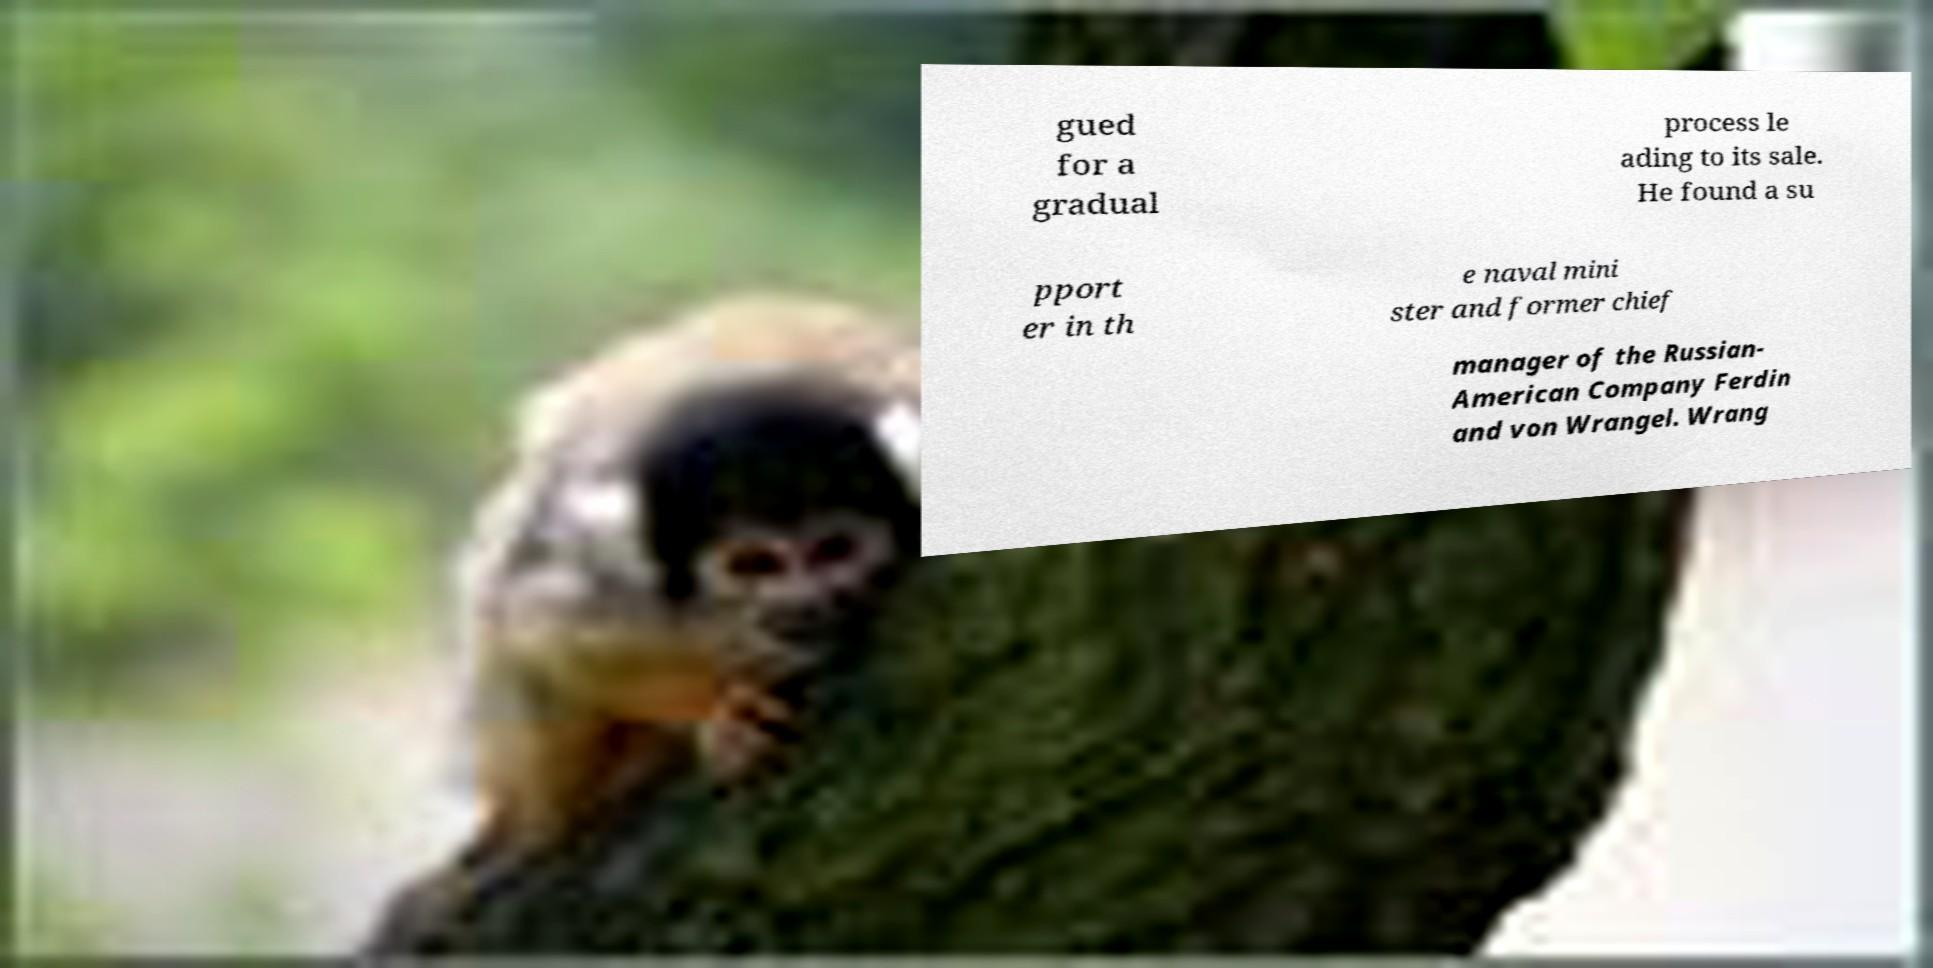Please read and relay the text visible in this image. What does it say? gued for a gradual process le ading to its sale. He found a su pport er in th e naval mini ster and former chief manager of the Russian- American Company Ferdin and von Wrangel. Wrang 